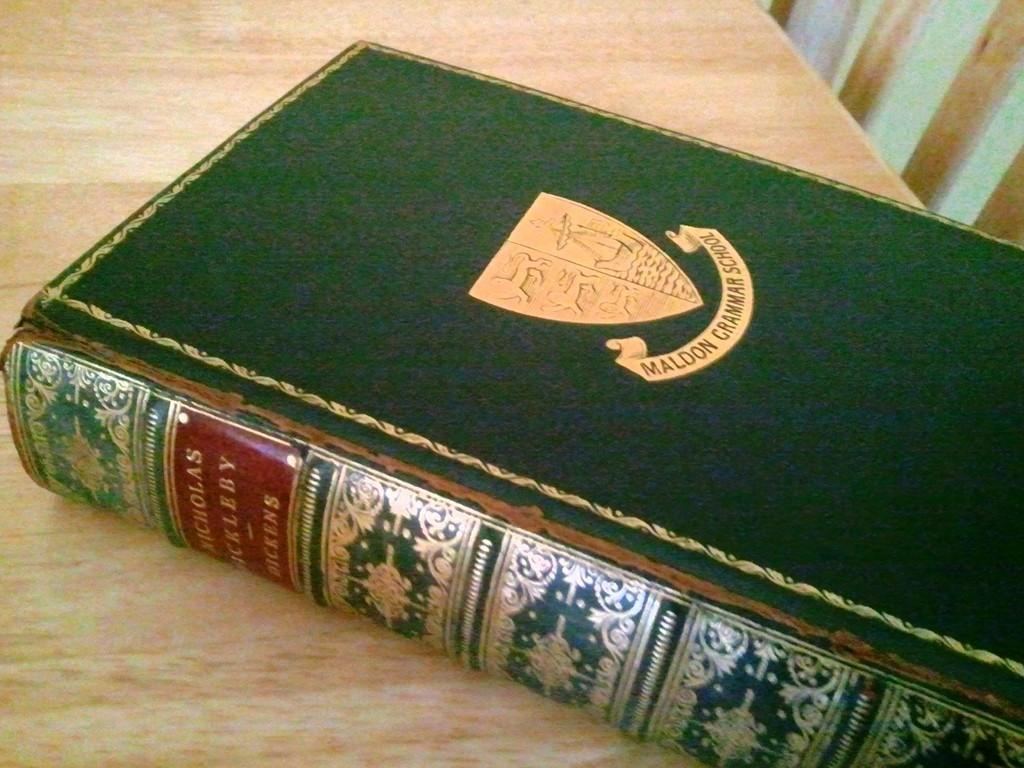Provide a one-sentence caption for the provided image. A book with a shield on the cover is from Maldon Grammar School. 